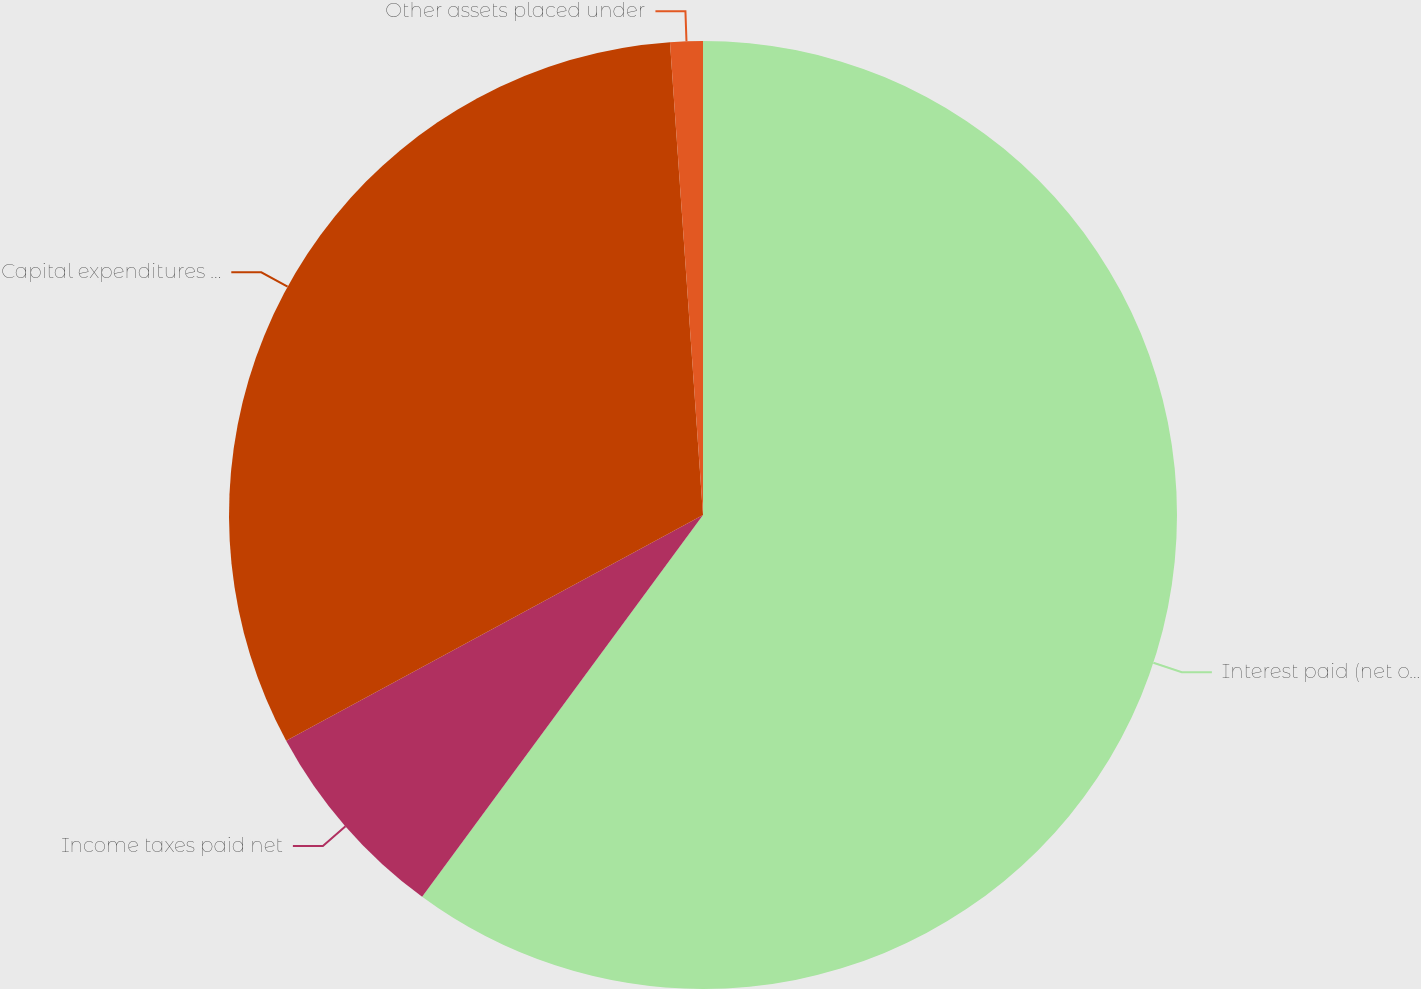Convert chart to OTSL. <chart><loc_0><loc_0><loc_500><loc_500><pie_chart><fcel>Interest paid (net of amounts<fcel>Income taxes paid net<fcel>Capital expenditures not paid<fcel>Other assets placed under<nl><fcel>60.1%<fcel>7.01%<fcel>31.79%<fcel>1.11%<nl></chart> 